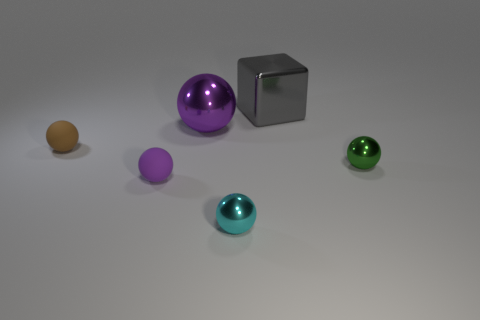How many objects are either shiny balls that are on the right side of the big gray metal block or shiny spheres that are on the left side of the tiny green ball?
Offer a terse response. 3. What number of tiny objects have the same color as the big shiny ball?
Your response must be concise. 1. What color is the other rubber thing that is the same shape as the tiny purple matte thing?
Provide a short and direct response. Brown. There is a metal object that is both behind the brown ball and in front of the gray shiny cube; what shape is it?
Ensure brevity in your answer.  Sphere. Is the number of large spheres greater than the number of tiny balls?
Provide a succinct answer. No. What material is the large purple sphere?
Make the answer very short. Metal. Is there any other thing that is the same size as the cyan ball?
Provide a succinct answer. Yes. What is the size of the green thing that is the same shape as the brown rubber thing?
Your answer should be very brief. Small. There is a small metal sphere left of the metal cube; are there any big gray shiny cubes that are behind it?
Keep it short and to the point. Yes. Is the metallic cube the same color as the large sphere?
Ensure brevity in your answer.  No. 